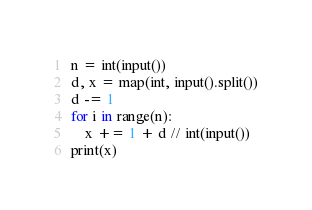Convert code to text. <code><loc_0><loc_0><loc_500><loc_500><_Python_>n = int(input())
d, x = map(int, input().split())
d -= 1
for i in range(n):
    x += 1 + d // int(input())
print(x)
</code> 